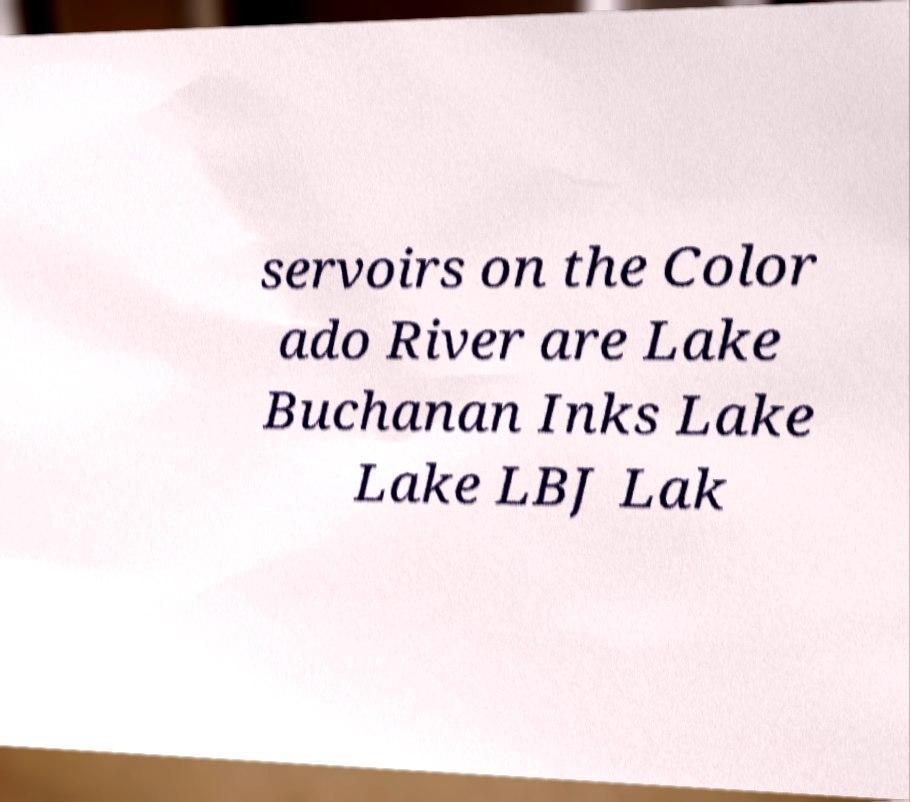There's text embedded in this image that I need extracted. Can you transcribe it verbatim? servoirs on the Color ado River are Lake Buchanan Inks Lake Lake LBJ Lak 